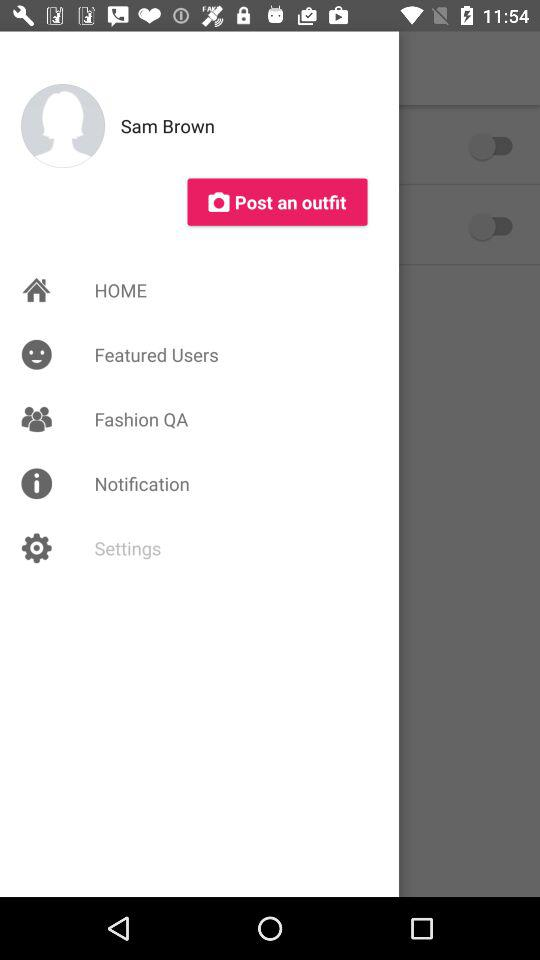What is the profile name? The profile name is Sam Brown. 